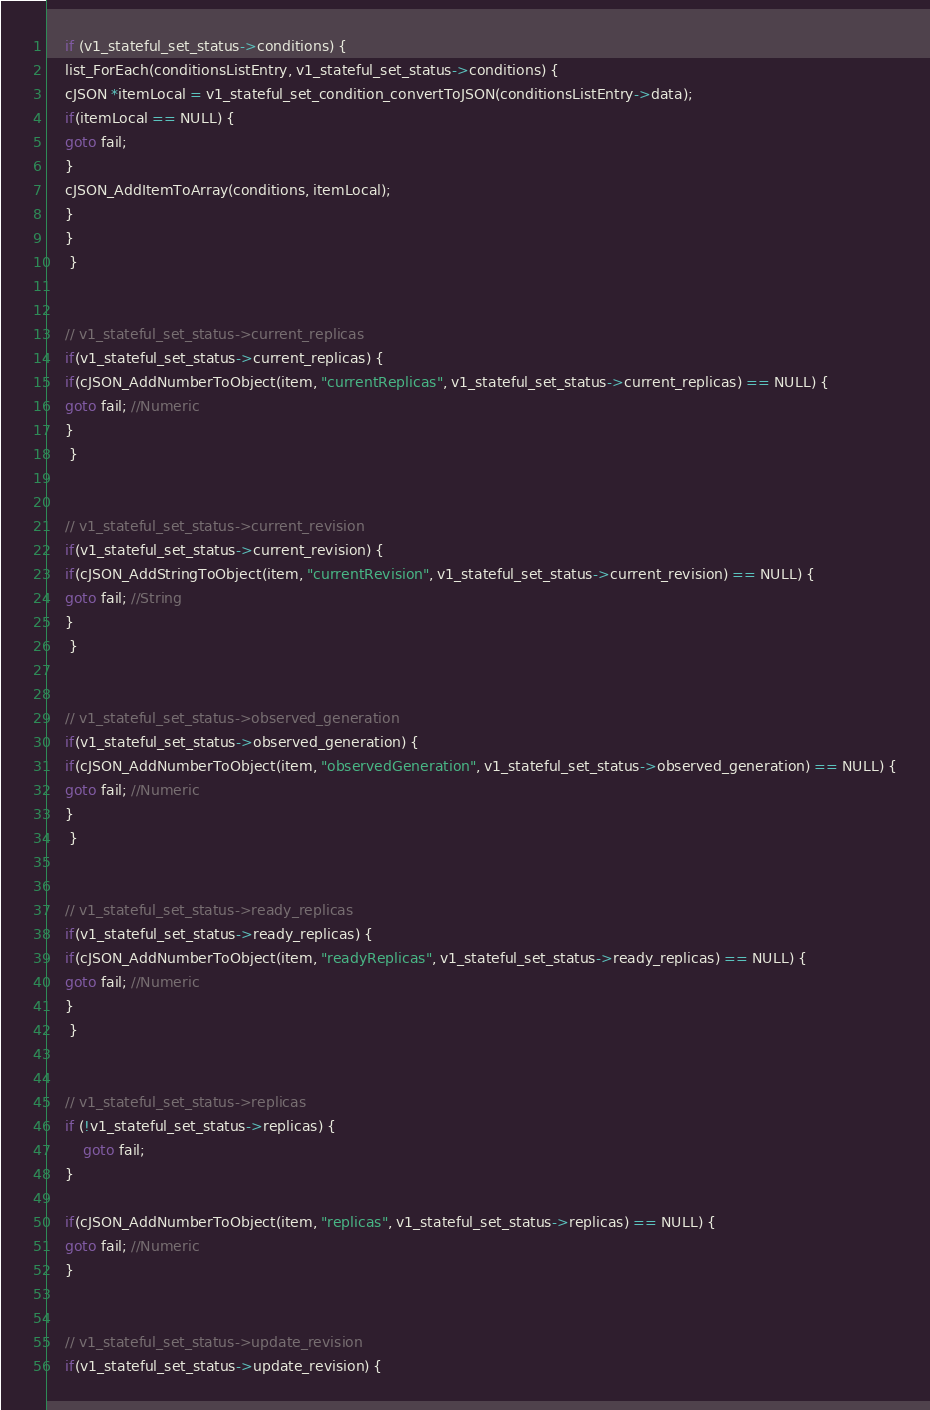Convert code to text. <code><loc_0><loc_0><loc_500><loc_500><_C_>    if (v1_stateful_set_status->conditions) {
    list_ForEach(conditionsListEntry, v1_stateful_set_status->conditions) {
    cJSON *itemLocal = v1_stateful_set_condition_convertToJSON(conditionsListEntry->data);
    if(itemLocal == NULL) {
    goto fail;
    }
    cJSON_AddItemToArray(conditions, itemLocal);
    }
    }
     } 


    // v1_stateful_set_status->current_replicas
    if(v1_stateful_set_status->current_replicas) { 
    if(cJSON_AddNumberToObject(item, "currentReplicas", v1_stateful_set_status->current_replicas) == NULL) {
    goto fail; //Numeric
    }
     } 


    // v1_stateful_set_status->current_revision
    if(v1_stateful_set_status->current_revision) { 
    if(cJSON_AddStringToObject(item, "currentRevision", v1_stateful_set_status->current_revision) == NULL) {
    goto fail; //String
    }
     } 


    // v1_stateful_set_status->observed_generation
    if(v1_stateful_set_status->observed_generation) { 
    if(cJSON_AddNumberToObject(item, "observedGeneration", v1_stateful_set_status->observed_generation) == NULL) {
    goto fail; //Numeric
    }
     } 


    // v1_stateful_set_status->ready_replicas
    if(v1_stateful_set_status->ready_replicas) { 
    if(cJSON_AddNumberToObject(item, "readyReplicas", v1_stateful_set_status->ready_replicas) == NULL) {
    goto fail; //Numeric
    }
     } 


    // v1_stateful_set_status->replicas
    if (!v1_stateful_set_status->replicas) {
        goto fail;
    }
    
    if(cJSON_AddNumberToObject(item, "replicas", v1_stateful_set_status->replicas) == NULL) {
    goto fail; //Numeric
    }


    // v1_stateful_set_status->update_revision
    if(v1_stateful_set_status->update_revision) { </code> 